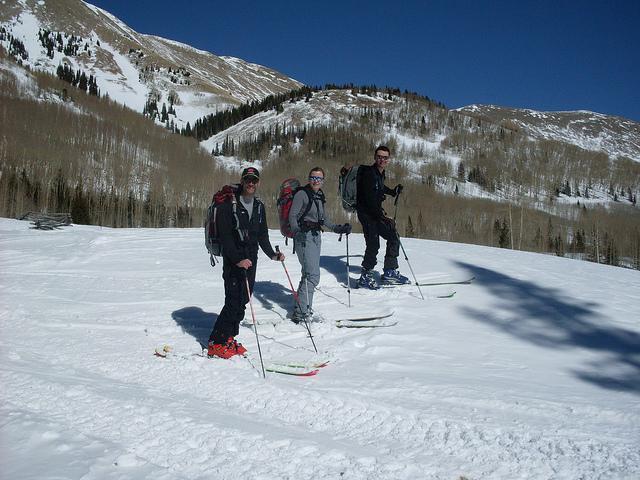Why are they off the path?
From the following set of four choices, select the accurate answer to respond to the question.
Options: Fighting, confused, buying tickets, posing. Posing. 